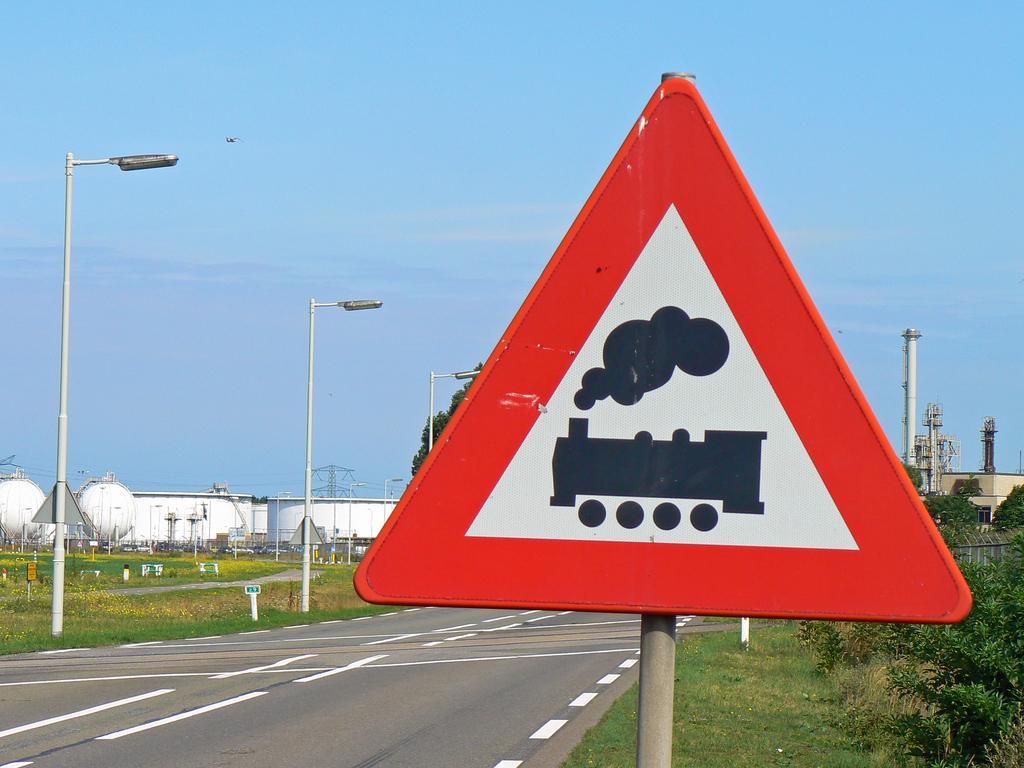Please provide a concise description of this image. In this picture I can see a signboard to a pole, and there is road, poles, lights, plants, trees, factory , reactors, and in the background there is sky. 